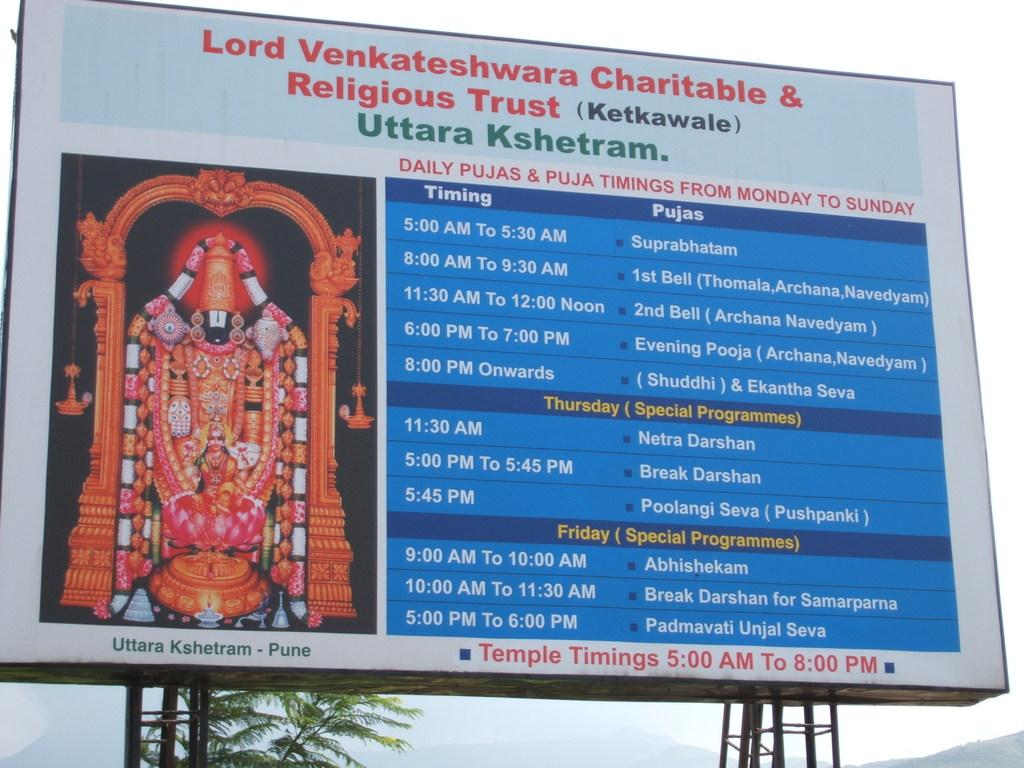Provide a one-sentence caption for the provided image. Big banner that includes timing and programming for temple daily times. 